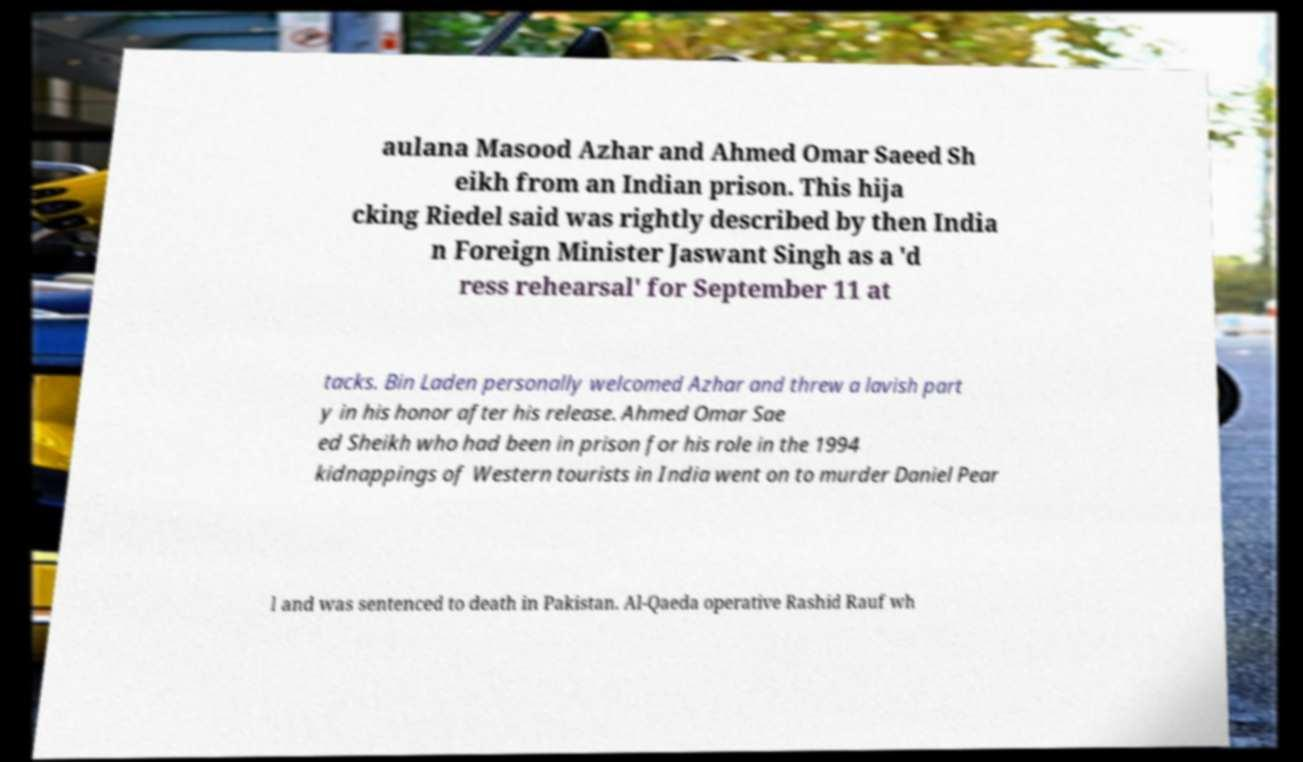For documentation purposes, I need the text within this image transcribed. Could you provide that? aulana Masood Azhar and Ahmed Omar Saeed Sh eikh from an Indian prison. This hija cking Riedel said was rightly described by then India n Foreign Minister Jaswant Singh as a 'd ress rehearsal' for September 11 at tacks. Bin Laden personally welcomed Azhar and threw a lavish part y in his honor after his release. Ahmed Omar Sae ed Sheikh who had been in prison for his role in the 1994 kidnappings of Western tourists in India went on to murder Daniel Pear l and was sentenced to death in Pakistan. Al-Qaeda operative Rashid Rauf wh 